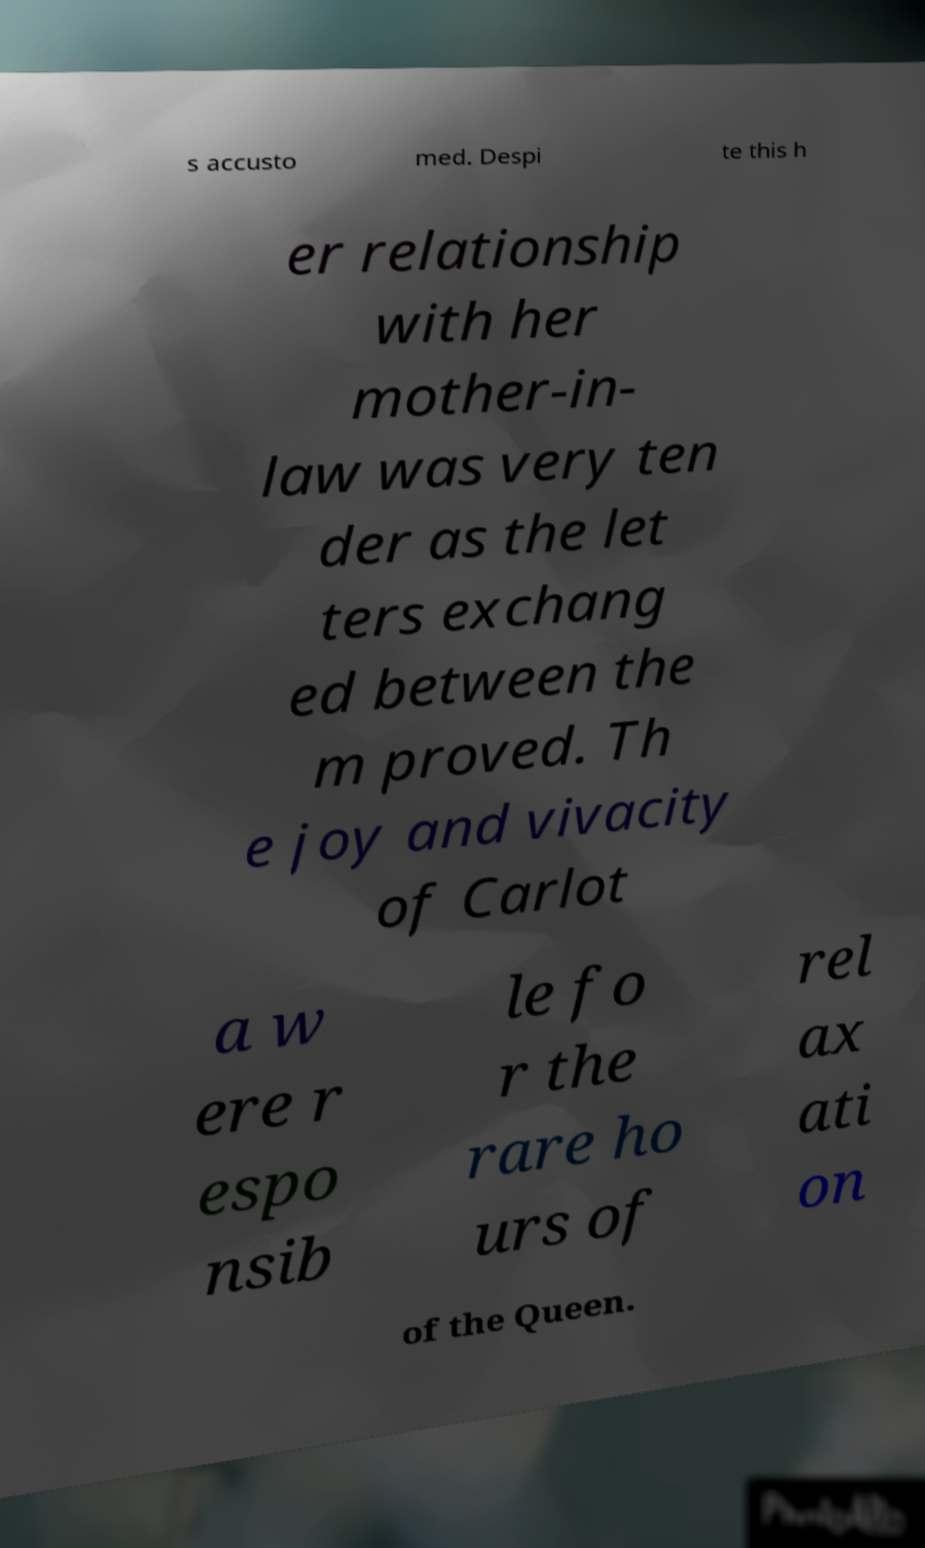There's text embedded in this image that I need extracted. Can you transcribe it verbatim? s accusto med. Despi te this h er relationship with her mother-in- law was very ten der as the let ters exchang ed between the m proved. Th e joy and vivacity of Carlot a w ere r espo nsib le fo r the rare ho urs of rel ax ati on of the Queen. 